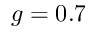Convert formula to latex. <formula><loc_0><loc_0><loc_500><loc_500>g = 0 . 7</formula> 